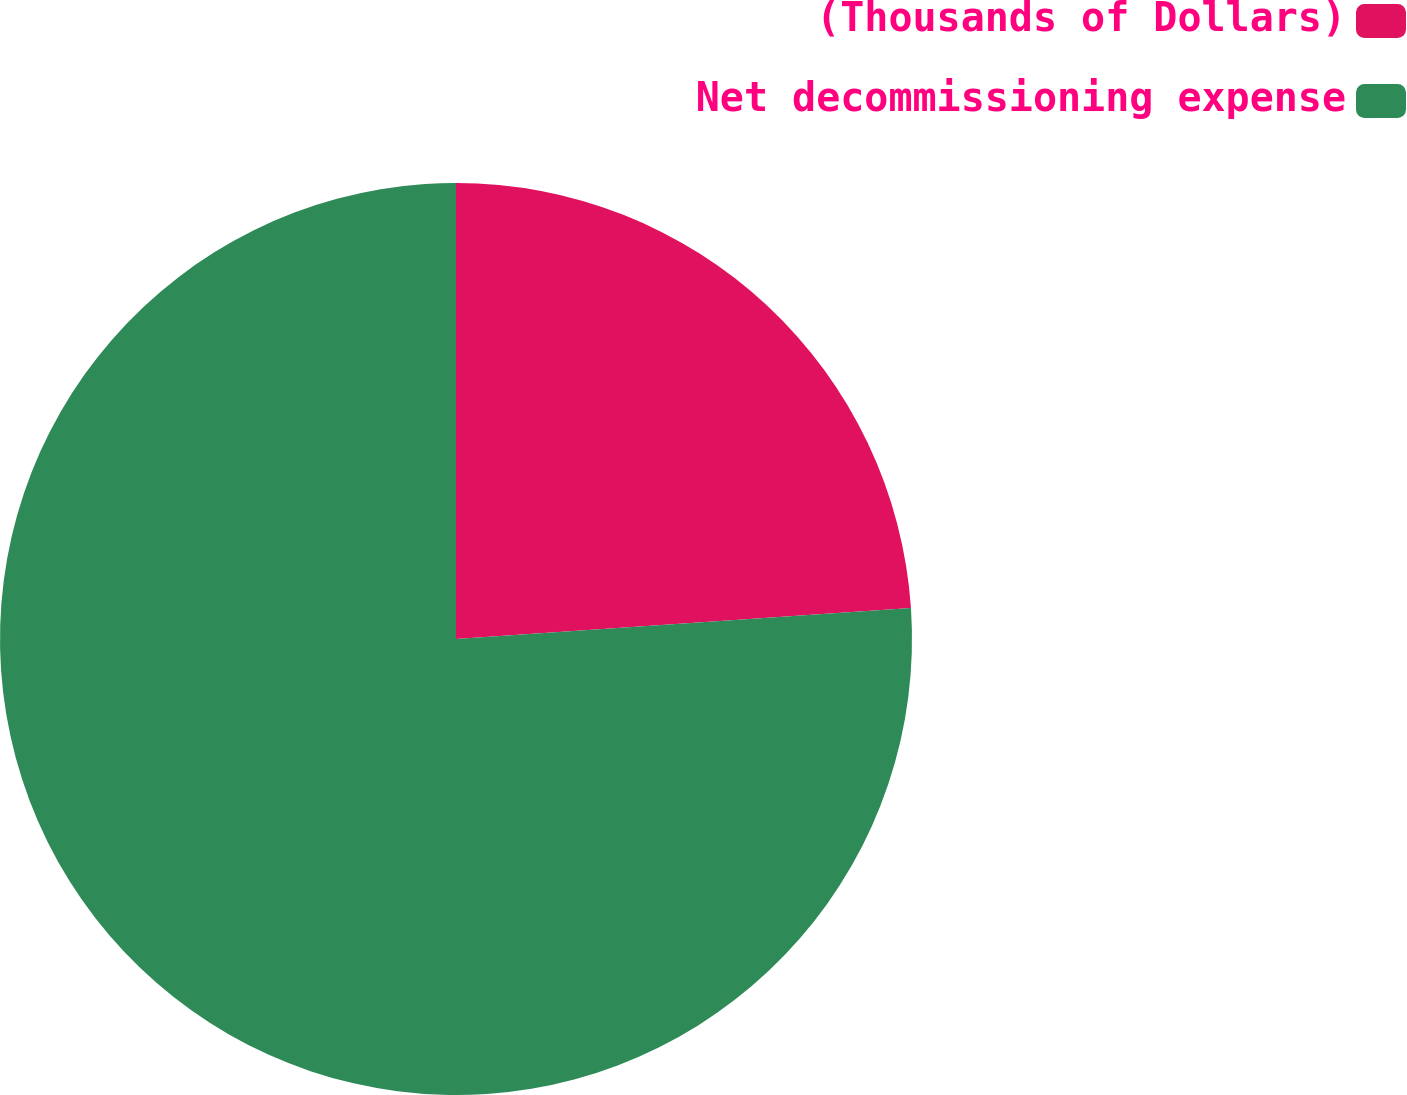<chart> <loc_0><loc_0><loc_500><loc_500><pie_chart><fcel>(Thousands of Dollars)<fcel>Net decommissioning expense<nl><fcel>23.92%<fcel>76.08%<nl></chart> 